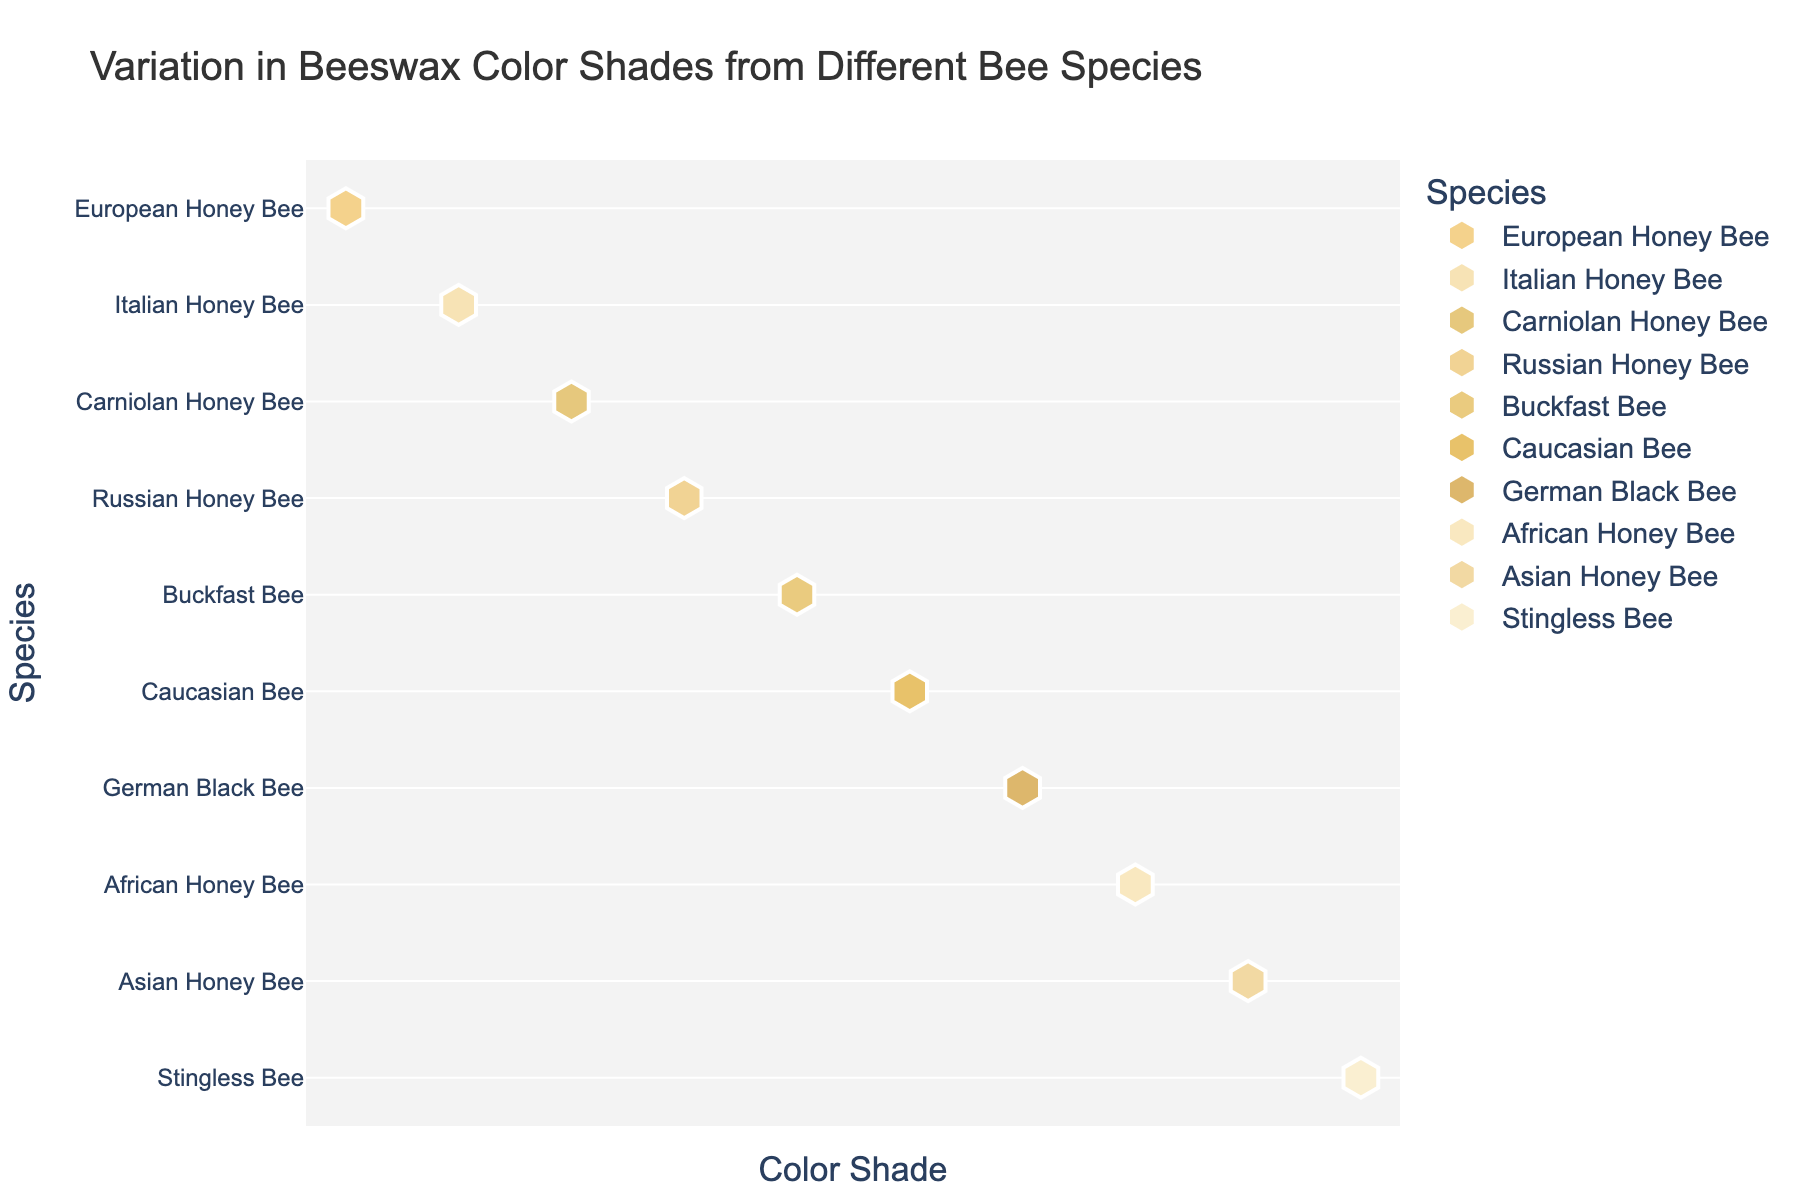What is the title of the strip plot? The title is displayed at the top of the plot. It reads "Variation in Beeswax Color Shades from Different Bee Species"
Answer: Variation in Beeswax Color Shades from Different Bee Species How many bee species are represented in the plot? We count each unique entry on the Y-axis labeled with the bee species' names.
Answer: 10 Which bee species has the lightest beeswax color? By examining the various color shades on the X-axis, "African Honey Bee" and "Stingless Bee" appear to have the lightest color shades.
Answer: African Honey Bee, Stingless Bee Which bee species has the darkest beeswax color? By examining the various color shades on the X-axis, the "German Black Bee" appears to have the darkest color shade.
Answer: German Black Bee What is the beeswax color shade for the Carniolan Honey Bee? The Carniolan Honey Bee's data point on the plot can be matched to its corresponding color, which is a dark yellow.
Answer: #E6C87D Compare the beeswax color shade of the Italian Honey Bee and the Asian Honey Bee. Which is lighter? By examining the shades on the plot, the Italian Honey Bee has a lighter color shade compared to the Asian Honey Bee.
Answer: Italian Honey Bee Which two bee species have the most similar beeswax color shades? Inspecting the plot, the European Honey Bee and Russian Honey Bee have very close, similar shades.
Answer: European Honey Bee, Russian Honey Bee Based on the plot, which species appears to have the most unique beeswax color? Observing the distribution of colors, the Caucasian Bee's beeswax color seems the most distinct among the others.
Answer: Caucasian Bee What shade is closest to the beeswax color shade of the Buckfast Bee? By locating the Buckfast Bee's position and comparing with nearby data points, the European Honey Bee's shade is closest.
Answer: European Honey Bee How does the beeswax color of the Stingless Bee compare to that of the German Black Bee? The beeswax color of the Stingless Bee is much lighter compared to the darker beeswax color of the German Black Bee.
Answer: Stingless Bee is lighter 